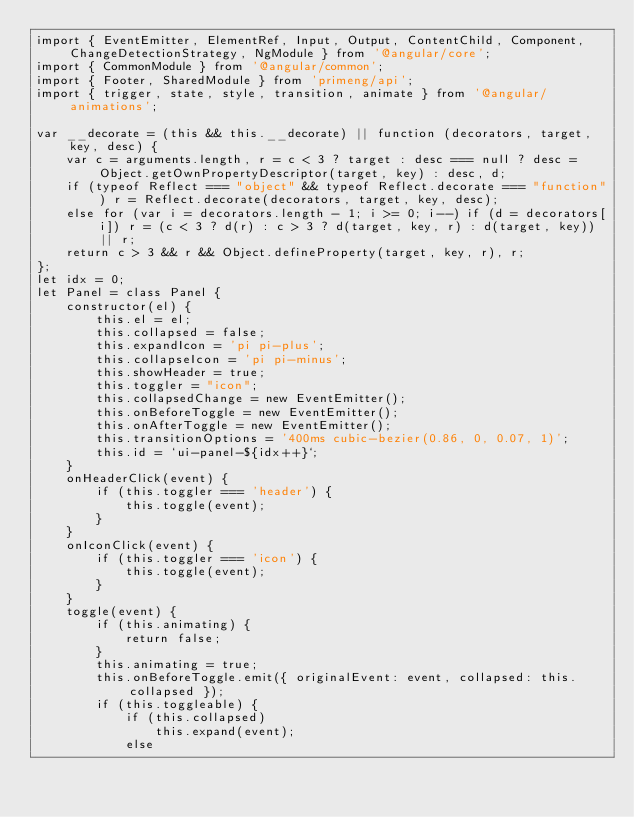<code> <loc_0><loc_0><loc_500><loc_500><_JavaScript_>import { EventEmitter, ElementRef, Input, Output, ContentChild, Component, ChangeDetectionStrategy, NgModule } from '@angular/core';
import { CommonModule } from '@angular/common';
import { Footer, SharedModule } from 'primeng/api';
import { trigger, state, style, transition, animate } from '@angular/animations';

var __decorate = (this && this.__decorate) || function (decorators, target, key, desc) {
    var c = arguments.length, r = c < 3 ? target : desc === null ? desc = Object.getOwnPropertyDescriptor(target, key) : desc, d;
    if (typeof Reflect === "object" && typeof Reflect.decorate === "function") r = Reflect.decorate(decorators, target, key, desc);
    else for (var i = decorators.length - 1; i >= 0; i--) if (d = decorators[i]) r = (c < 3 ? d(r) : c > 3 ? d(target, key, r) : d(target, key)) || r;
    return c > 3 && r && Object.defineProperty(target, key, r), r;
};
let idx = 0;
let Panel = class Panel {
    constructor(el) {
        this.el = el;
        this.collapsed = false;
        this.expandIcon = 'pi pi-plus';
        this.collapseIcon = 'pi pi-minus';
        this.showHeader = true;
        this.toggler = "icon";
        this.collapsedChange = new EventEmitter();
        this.onBeforeToggle = new EventEmitter();
        this.onAfterToggle = new EventEmitter();
        this.transitionOptions = '400ms cubic-bezier(0.86, 0, 0.07, 1)';
        this.id = `ui-panel-${idx++}`;
    }
    onHeaderClick(event) {
        if (this.toggler === 'header') {
            this.toggle(event);
        }
    }
    onIconClick(event) {
        if (this.toggler === 'icon') {
            this.toggle(event);
        }
    }
    toggle(event) {
        if (this.animating) {
            return false;
        }
        this.animating = true;
        this.onBeforeToggle.emit({ originalEvent: event, collapsed: this.collapsed });
        if (this.toggleable) {
            if (this.collapsed)
                this.expand(event);
            else</code> 